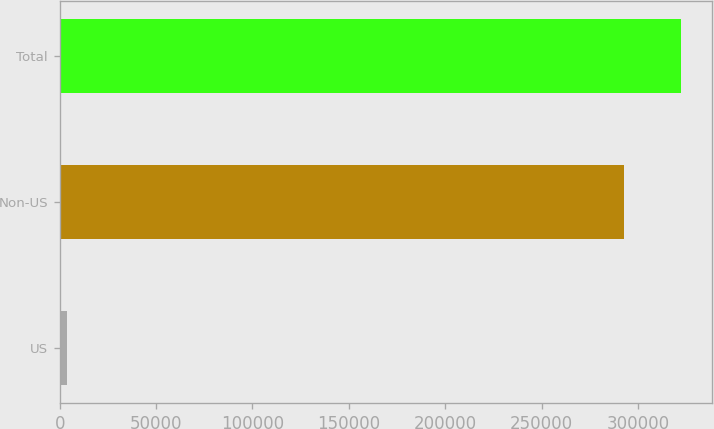Convert chart. <chart><loc_0><loc_0><loc_500><loc_500><bar_chart><fcel>US<fcel>Non-US<fcel>Total<nl><fcel>3743<fcel>292975<fcel>322272<nl></chart> 